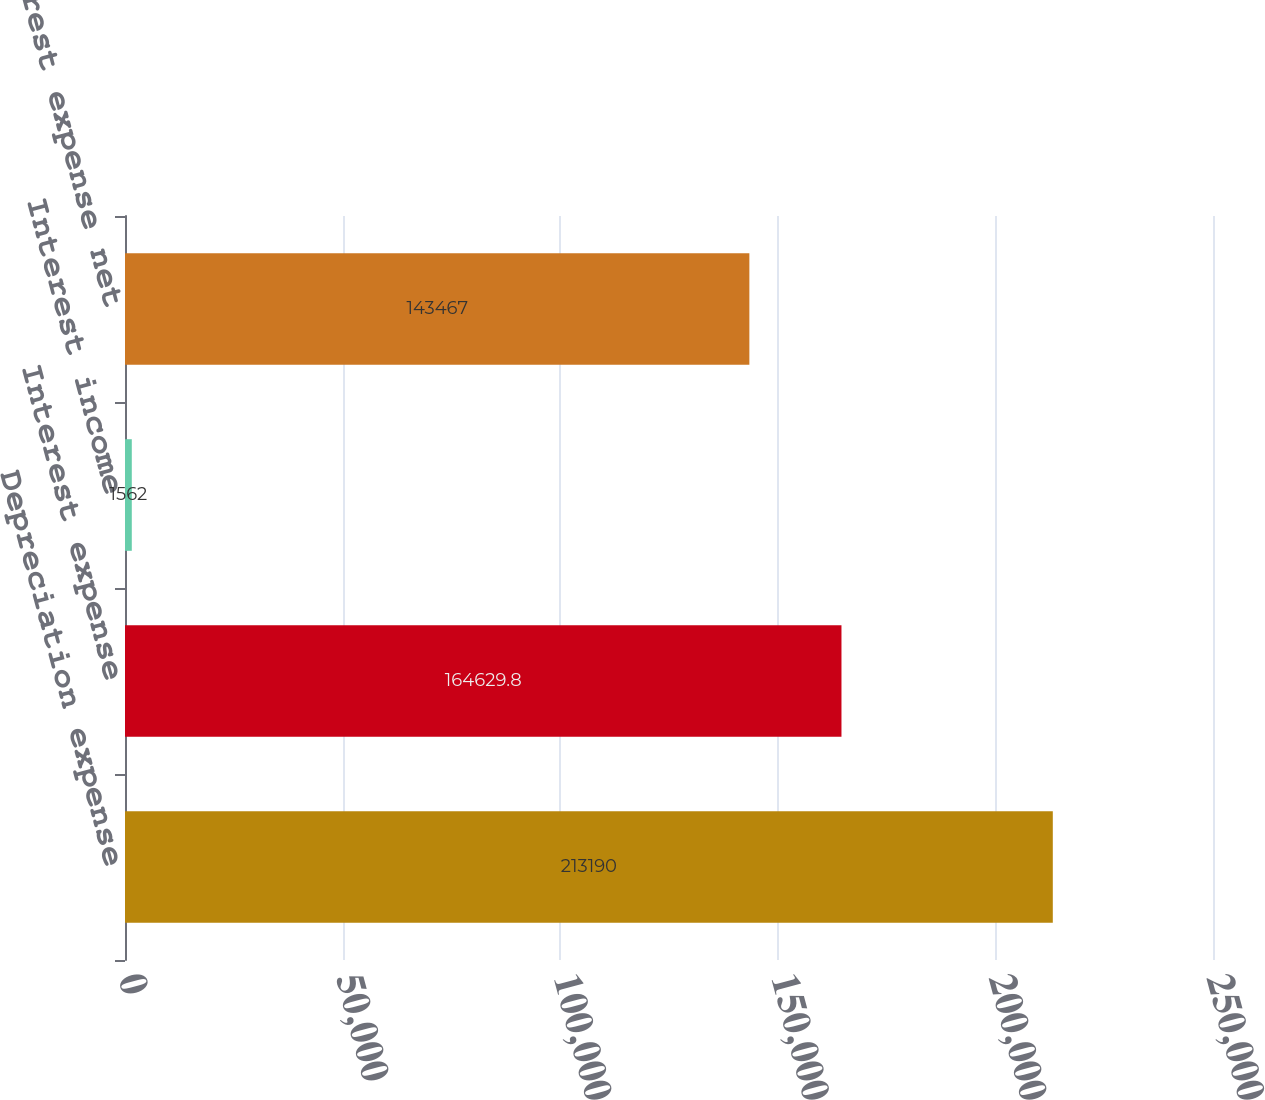Convert chart. <chart><loc_0><loc_0><loc_500><loc_500><bar_chart><fcel>Depreciation expense<fcel>Interest expense<fcel>Interest income<fcel>Interest expense net<nl><fcel>213190<fcel>164630<fcel>1562<fcel>143467<nl></chart> 